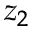Convert formula to latex. <formula><loc_0><loc_0><loc_500><loc_500>z _ { 2 }</formula> 